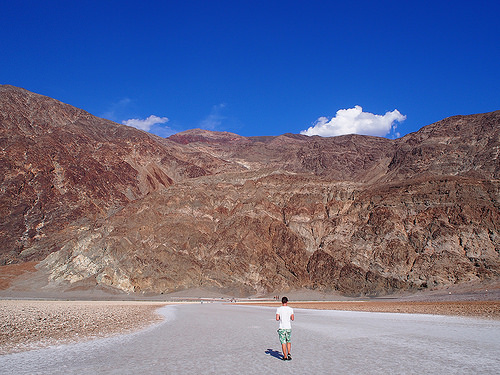<image>
Is the person on the mountain? No. The person is not positioned on the mountain. They may be near each other, but the person is not supported by or resting on top of the mountain. Is there a man behind the mountain? No. The man is not behind the mountain. From this viewpoint, the man appears to be positioned elsewhere in the scene. 